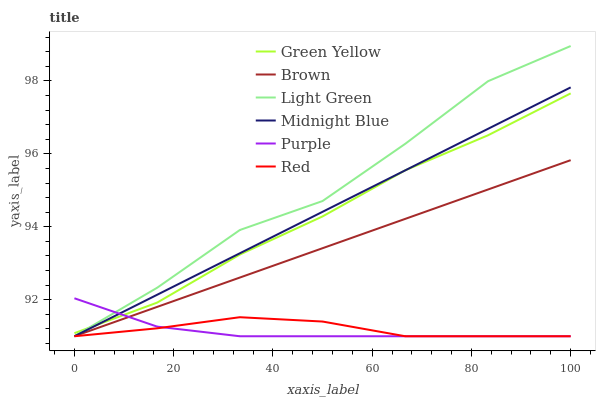Does Purple have the minimum area under the curve?
Answer yes or no. Yes. Does Light Green have the maximum area under the curve?
Answer yes or no. Yes. Does Midnight Blue have the minimum area under the curve?
Answer yes or no. No. Does Midnight Blue have the maximum area under the curve?
Answer yes or no. No. Is Midnight Blue the smoothest?
Answer yes or no. Yes. Is Light Green the roughest?
Answer yes or no. Yes. Is Purple the smoothest?
Answer yes or no. No. Is Purple the roughest?
Answer yes or no. No. Does Green Yellow have the lowest value?
Answer yes or no. No. Does Light Green have the highest value?
Answer yes or no. Yes. Does Midnight Blue have the highest value?
Answer yes or no. No. Is Brown less than Green Yellow?
Answer yes or no. Yes. Is Green Yellow greater than Red?
Answer yes or no. Yes. Does Purple intersect Green Yellow?
Answer yes or no. Yes. Is Purple less than Green Yellow?
Answer yes or no. No. Is Purple greater than Green Yellow?
Answer yes or no. No. Does Brown intersect Green Yellow?
Answer yes or no. No. 